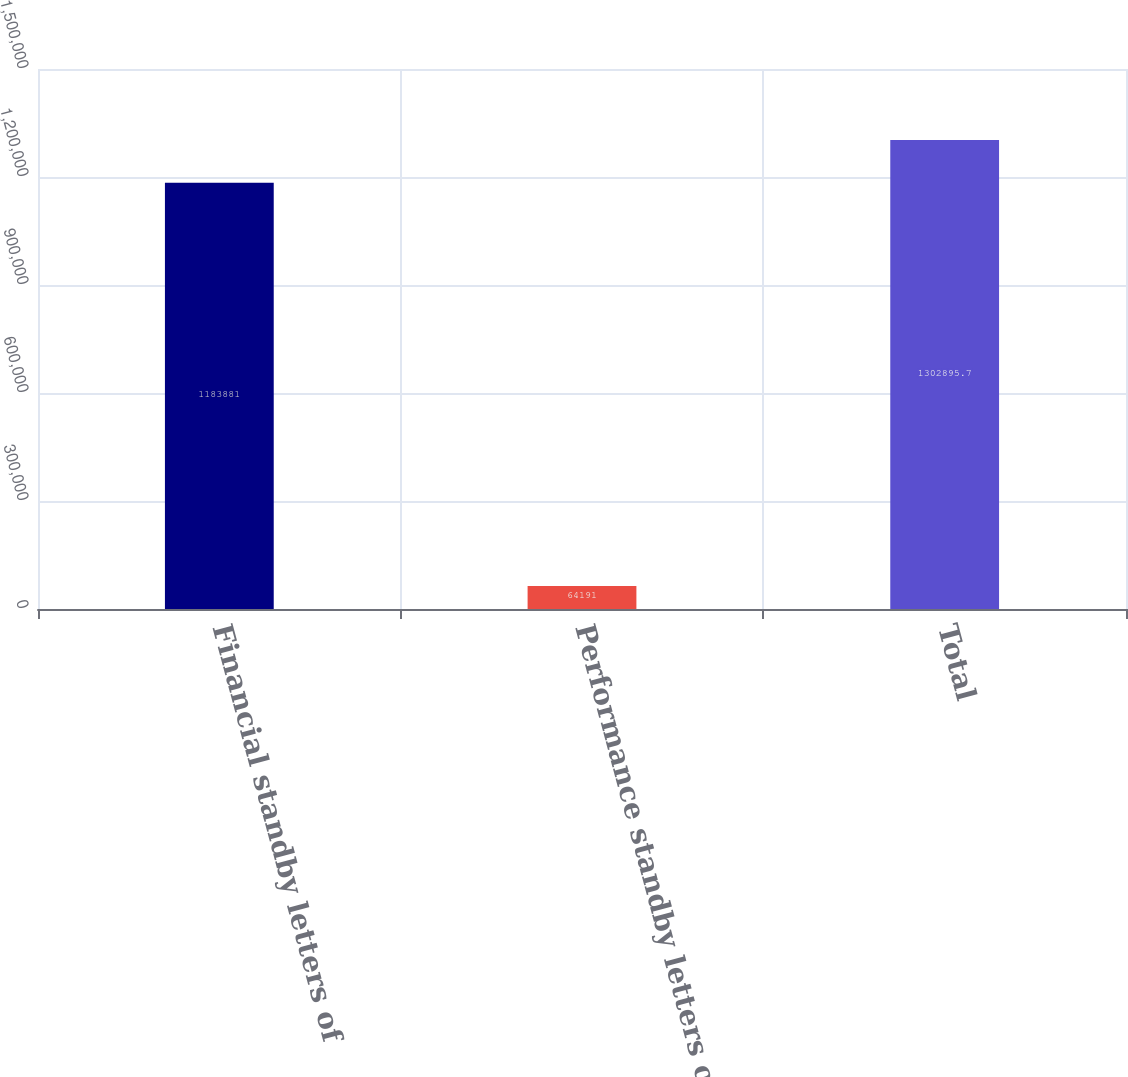<chart> <loc_0><loc_0><loc_500><loc_500><bar_chart><fcel>Financial standby letters of<fcel>Performance standby letters of<fcel>Total<nl><fcel>1.18388e+06<fcel>64191<fcel>1.3029e+06<nl></chart> 